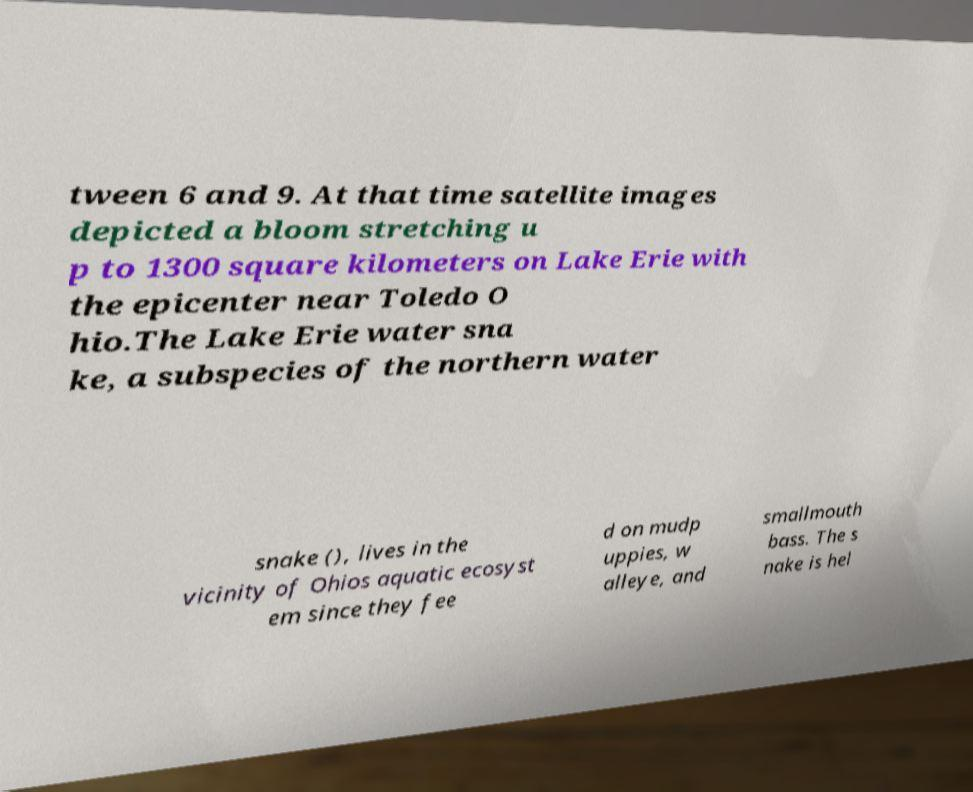What messages or text are displayed in this image? I need them in a readable, typed format. tween 6 and 9. At that time satellite images depicted a bloom stretching u p to 1300 square kilometers on Lake Erie with the epicenter near Toledo O hio.The Lake Erie water sna ke, a subspecies of the northern water snake (), lives in the vicinity of Ohios aquatic ecosyst em since they fee d on mudp uppies, w alleye, and smallmouth bass. The s nake is hel 